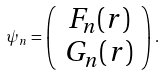<formula> <loc_0><loc_0><loc_500><loc_500>\psi _ { n } = \left ( \begin{array} { c } F _ { n } ( r ) \\ G _ { n } ( r ) \end{array} \right ) .</formula> 